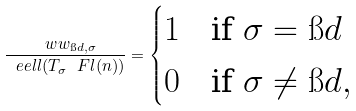Convert formula to latex. <formula><loc_0><loc_0><loc_500><loc_500>\frac { \ w w _ { \i d , \sigma } } { \ e e l l ( T _ { \sigma } \ F l ( n ) ) } = \begin{cases} 1 & \text {if } \sigma = \i d \\ 0 & \text {if } \sigma \not = \i d , \end{cases}</formula> 